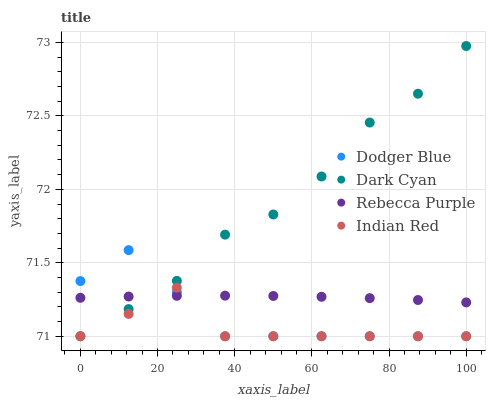Does Indian Red have the minimum area under the curve?
Answer yes or no. Yes. Does Dark Cyan have the maximum area under the curve?
Answer yes or no. Yes. Does Dodger Blue have the minimum area under the curve?
Answer yes or no. No. Does Dodger Blue have the maximum area under the curve?
Answer yes or no. No. Is Rebecca Purple the smoothest?
Answer yes or no. Yes. Is Indian Red the roughest?
Answer yes or no. Yes. Is Dodger Blue the smoothest?
Answer yes or no. No. Is Dodger Blue the roughest?
Answer yes or no. No. Does Dark Cyan have the lowest value?
Answer yes or no. Yes. Does Rebecca Purple have the lowest value?
Answer yes or no. No. Does Dark Cyan have the highest value?
Answer yes or no. Yes. Does Dodger Blue have the highest value?
Answer yes or no. No. Does Dodger Blue intersect Rebecca Purple?
Answer yes or no. Yes. Is Dodger Blue less than Rebecca Purple?
Answer yes or no. No. Is Dodger Blue greater than Rebecca Purple?
Answer yes or no. No. 